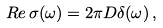<formula> <loc_0><loc_0><loc_500><loc_500>R e \, \sigma ( \omega ) = 2 \pi D \delta ( \omega ) \, ,</formula> 